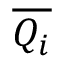<formula> <loc_0><loc_0><loc_500><loc_500>\overline { { Q _ { i } } }</formula> 